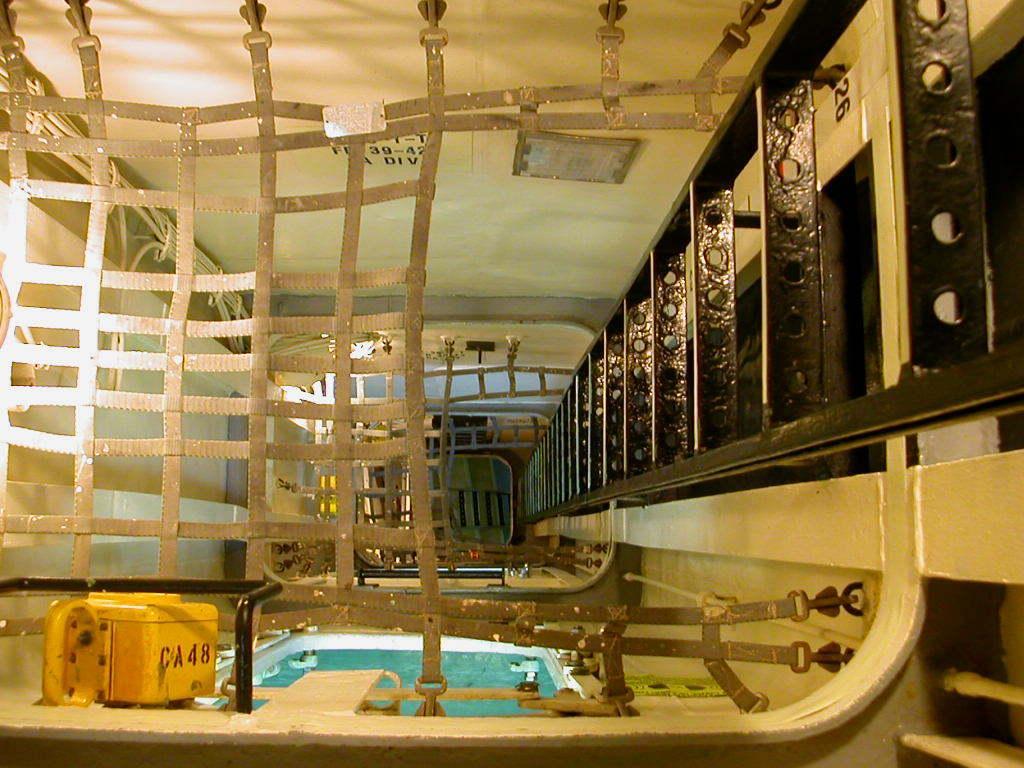How would you summarize this image in a sentence or two? In the image we can see there is a yellow box on which it's written "CA48" in front of it there is a swimming pool area and on opposite side its a black colour ladder. On the top its a wall and the belts are arranged as a fencing. 